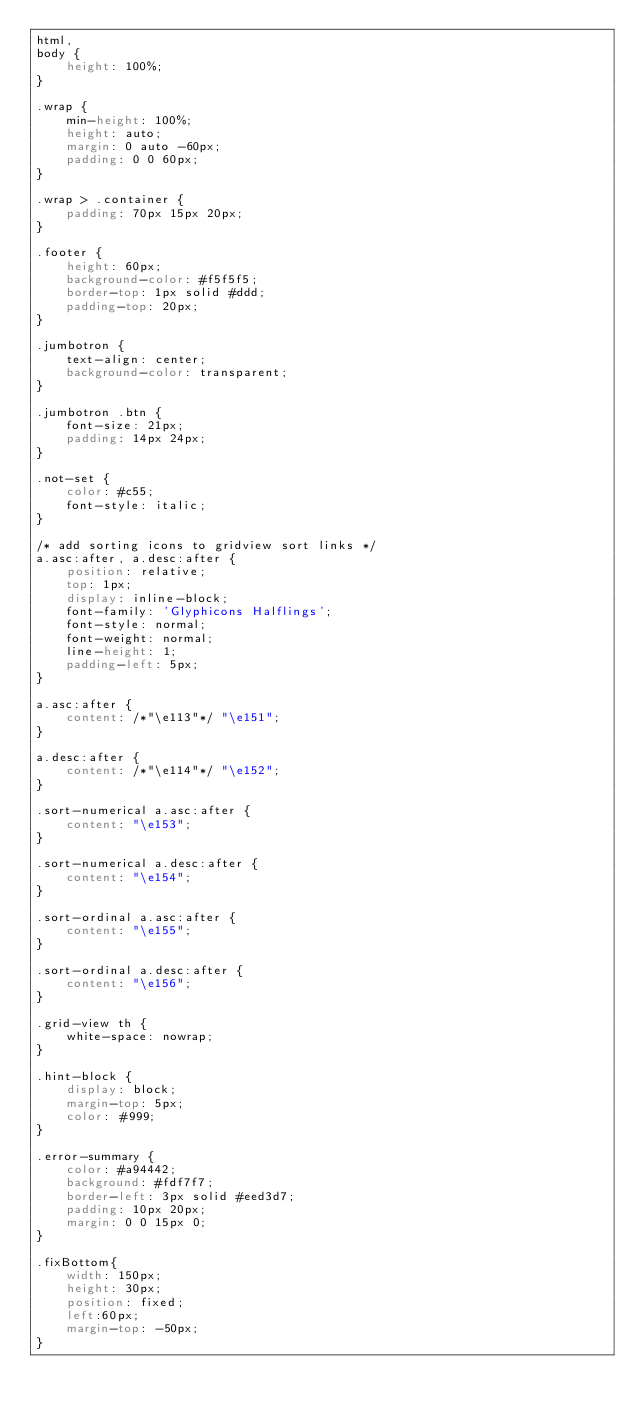Convert code to text. <code><loc_0><loc_0><loc_500><loc_500><_CSS_>html,
body {
    height: 100%;
}

.wrap {
    min-height: 100%;
    height: auto;
    margin: 0 auto -60px;
    padding: 0 0 60px;
}

.wrap > .container {
    padding: 70px 15px 20px;
}

.footer {
    height: 60px;
    background-color: #f5f5f5;
    border-top: 1px solid #ddd;
    padding-top: 20px;
}

.jumbotron {
    text-align: center;
    background-color: transparent;
}

.jumbotron .btn {
    font-size: 21px;
    padding: 14px 24px;
}

.not-set {
    color: #c55;
    font-style: italic;
}

/* add sorting icons to gridview sort links */
a.asc:after, a.desc:after {
    position: relative;
    top: 1px;
    display: inline-block;
    font-family: 'Glyphicons Halflings';
    font-style: normal;
    font-weight: normal;
    line-height: 1;
    padding-left: 5px;
}

a.asc:after {
    content: /*"\e113"*/ "\e151";
}

a.desc:after {
    content: /*"\e114"*/ "\e152";
}

.sort-numerical a.asc:after {
    content: "\e153";
}

.sort-numerical a.desc:after {
    content: "\e154";
}

.sort-ordinal a.asc:after {
    content: "\e155";
}

.sort-ordinal a.desc:after {
    content: "\e156";
}

.grid-view th {
    white-space: nowrap;
}

.hint-block {
    display: block;
    margin-top: 5px;
    color: #999;
}

.error-summary {
    color: #a94442;
    background: #fdf7f7;
    border-left: 3px solid #eed3d7;
    padding: 10px 20px;
    margin: 0 0 15px 0;
}

.fixBottom{
    width: 150px;
    height: 30px;
    position: fixed;
    left:60px;
    margin-top: -50px;
}
</code> 